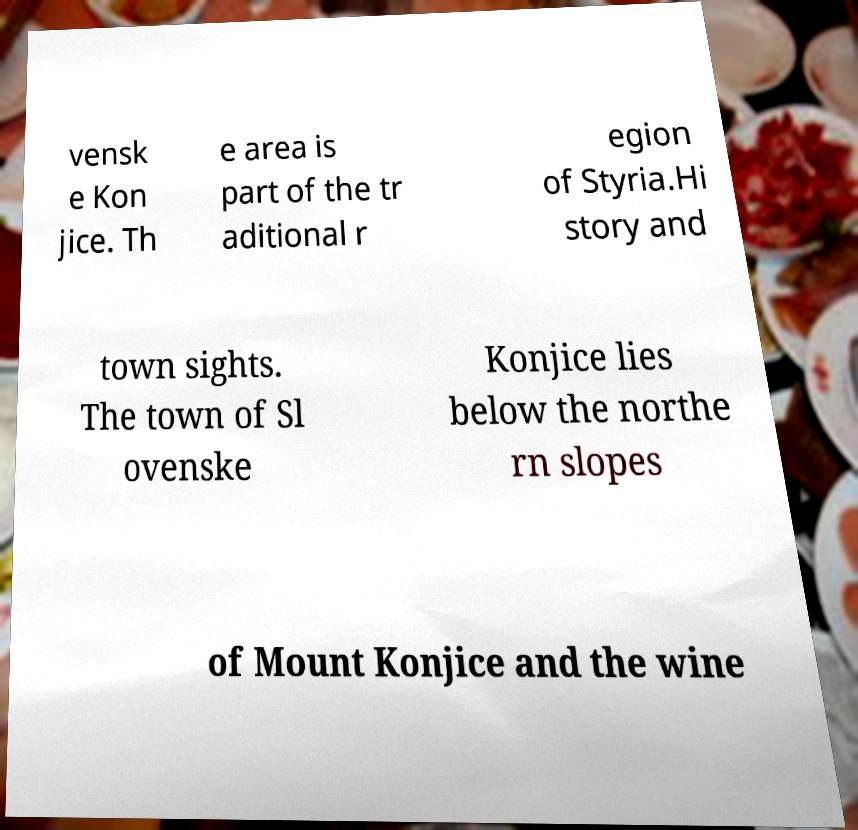Please read and relay the text visible in this image. What does it say? vensk e Kon jice. Th e area is part of the tr aditional r egion of Styria.Hi story and town sights. The town of Sl ovenske Konjice lies below the northe rn slopes of Mount Konjice and the wine 